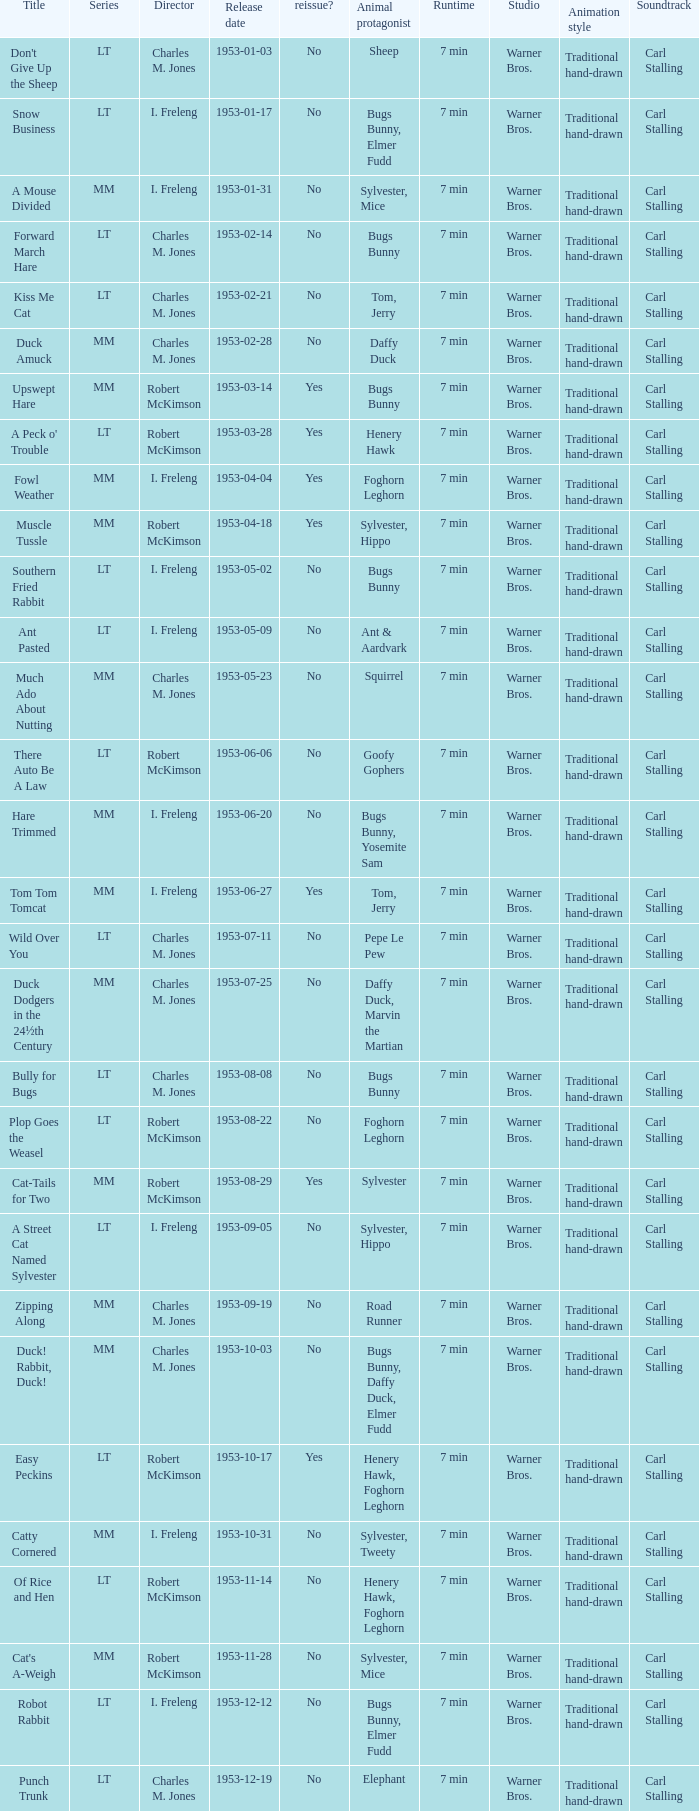What's the series of Kiss Me Cat? LT. 